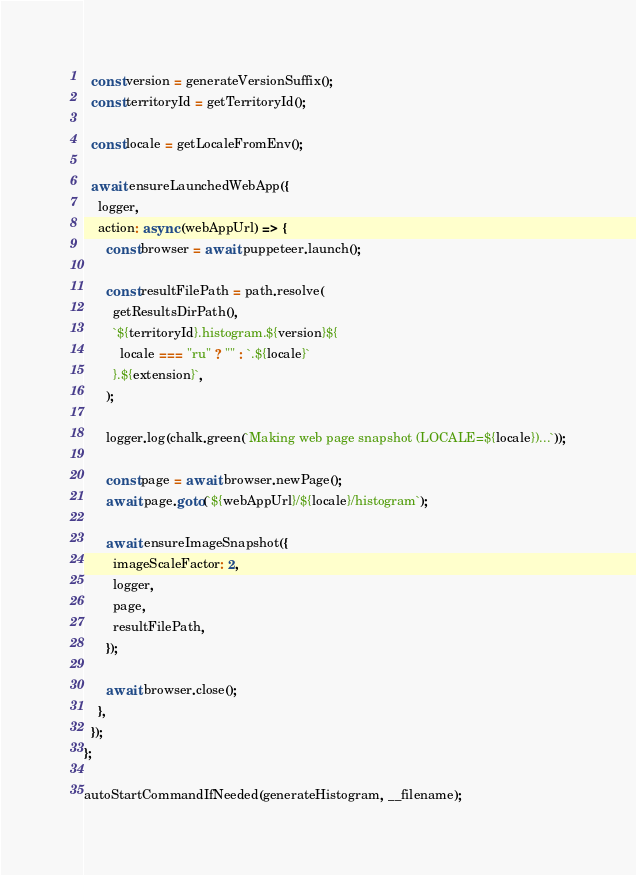<code> <loc_0><loc_0><loc_500><loc_500><_TypeScript_>  const version = generateVersionSuffix();
  const territoryId = getTerritoryId();

  const locale = getLocaleFromEnv();

  await ensureLaunchedWebApp({
    logger,
    action: async (webAppUrl) => {
      const browser = await puppeteer.launch();

      const resultFilePath = path.resolve(
        getResultsDirPath(),
        `${territoryId}.histogram.${version}${
          locale === "ru" ? "" : `.${locale}`
        }.${extension}`,
      );

      logger.log(chalk.green(`Making web page snapshot (LOCALE=${locale})...`));

      const page = await browser.newPage();
      await page.goto(`${webAppUrl}/${locale}/histogram`);

      await ensureImageSnapshot({
        imageScaleFactor: 2,
        logger,
        page,
        resultFilePath,
      });

      await browser.close();
    },
  });
};

autoStartCommandIfNeeded(generateHistogram, __filename);
</code> 